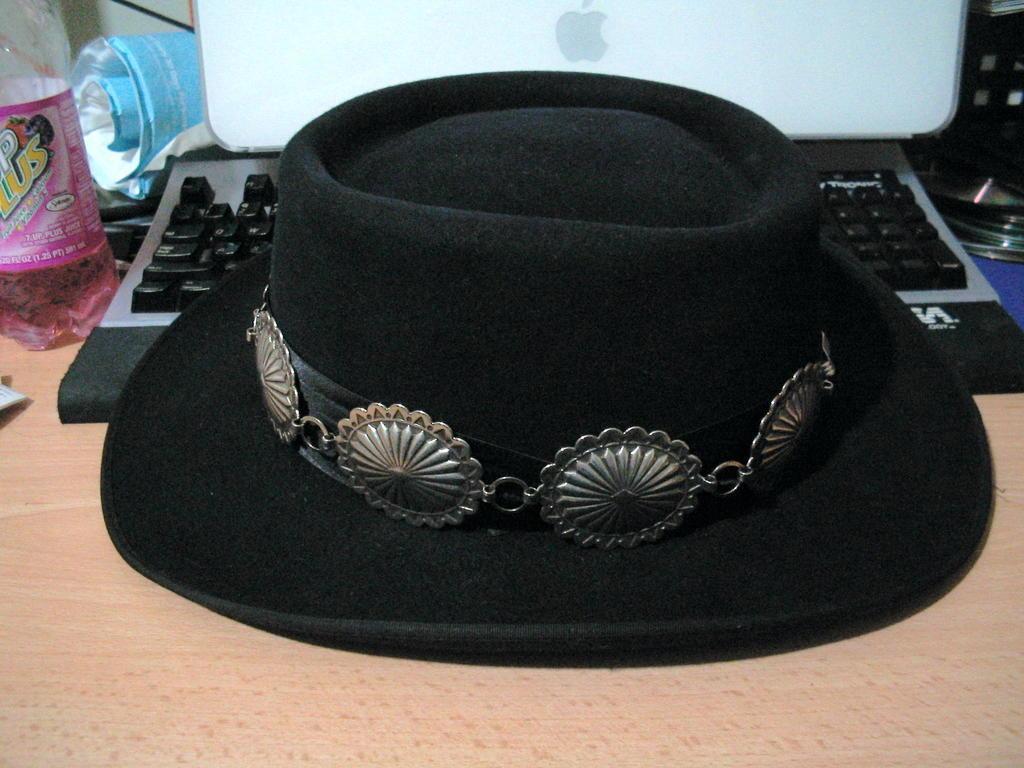Please provide a concise description of this image. There is a black hat placed on a keyboard and there are some other objects behind it. 